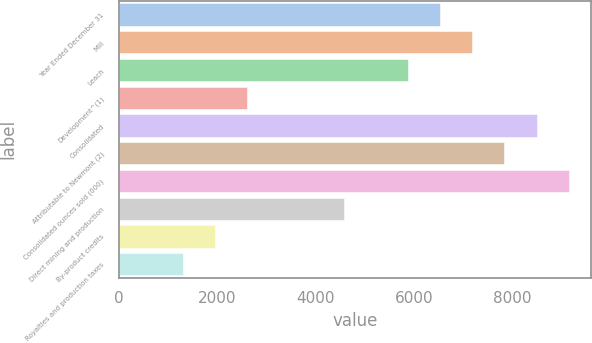Convert chart to OTSL. <chart><loc_0><loc_0><loc_500><loc_500><bar_chart><fcel>Year Ended December 31<fcel>Mill<fcel>Leach<fcel>Development^(1)<fcel>Consolidated<fcel>Attributable to Newmont (2)<fcel>Consolidated ounces sold (000)<fcel>Direct mining and production<fcel>By-product credits<fcel>Royalties and production taxes<nl><fcel>6534<fcel>7187.1<fcel>5880.9<fcel>2615.4<fcel>8493.3<fcel>7840.2<fcel>9146.4<fcel>4574.7<fcel>1962.3<fcel>1309.2<nl></chart> 